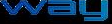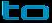What words can you see in these images in sequence, separated by a semicolon? way; to 